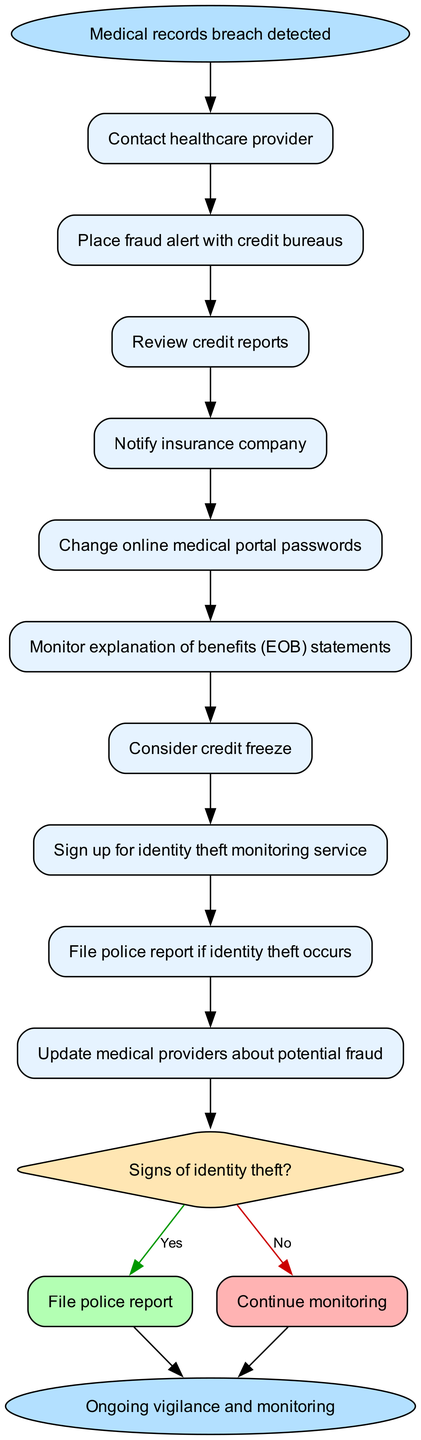What is the starting point of the workflow? The starting point is labeled as "Medical records breach detected" in the diagram and serves as the entry node for the process.
Answer: Medical records breach detected How many steps are there in the workflow? There are 9 steps listed in the workflow that follow the starting point and precede the decision point.
Answer: 9 What is the first action after detecting a breach? The first action is to "Contact healthcare provider," which is the first step indicated in the workflow after the starting point.
Answer: Contact healthcare provider What happens if there are signs of identity theft? If there are signs of identity theft, the next step is to "File police report," as indicated by the "Yes" branch of the decision point.
Answer: File police report What does the workflow suggest if there are no signs of identity theft? If there are no signs of identity theft, the recommendation is to "Continue monitoring," which is the pathway indicated by the "No" branch of the decision point.
Answer: Continue monitoring How many total nodes are in the diagram? The diagram consists of 12 total nodes: 1 start node, 9 steps, 1 decision node, and 1 end node.
Answer: 12 What is the endpoint of the workflow? The endpoint of the workflow is labeled "Ongoing vigilance and monitoring," which signifies the conclusion of the process regardless of the decision outcome.
Answer: Ongoing vigilance and monitoring What action follows changing online medical portal passwords? The action that follows changing online medical portal passwords is "Monitor explanation of benefits (EOB) statements," which is the next step indicated in the workflow.
Answer: Monitor explanation of benefits (EOB) statements What are the actions taken after reviewing credit reports? After reviewing credit reports, the workflow proceeds to "Notify insurance company," which is the next step in the sequence.
Answer: Notify insurance company 